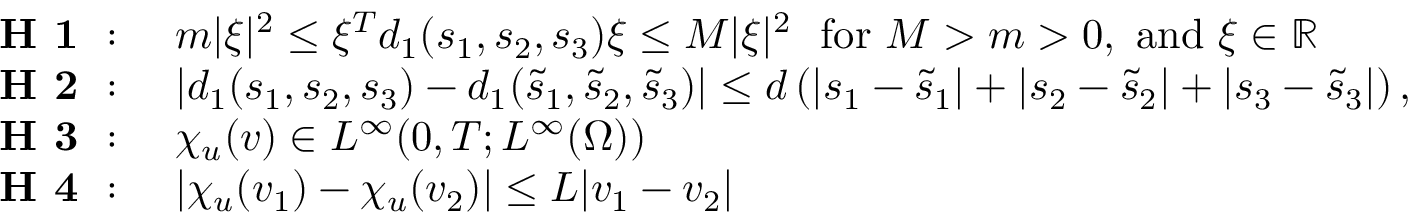Convert formula to latex. <formula><loc_0><loc_0><loc_500><loc_500>\begin{array} { r l } { H 1 \colon } & { m | \xi | ^ { 2 } \leq \xi ^ { T } d _ { 1 } ( s _ { 1 } , s _ { 2 } , s _ { 3 } ) \xi \leq M | \xi | ^ { 2 } f o r M > m > 0 , a n d \xi \in \mathbb { R } } \\ { H 2 \colon } & { | d _ { 1 } ( s _ { 1 } , s _ { 2 } , s _ { 3 } ) - d _ { 1 } ( \tilde { s } _ { 1 } , \tilde { s } _ { 2 } , \tilde { s } _ { 3 } ) | \leq d \left ( | s _ { 1 } - \tilde { s } _ { 1 } | + | s _ { 2 } - \tilde { s } _ { 2 } | + | s _ { 3 } - \tilde { s } _ { 3 } | \right ) , } \\ { H 3 \colon } & { \chi _ { u } ( v ) \in L ^ { \infty } ( 0 , T ; L ^ { \infty } ( \Omega ) ) } \\ { H 4 \colon } & { | \chi _ { u } ( v _ { 1 } ) - \chi _ { u } ( v _ { 2 } ) | \leq L | v _ { 1 } - v _ { 2 } | } \end{array}</formula> 